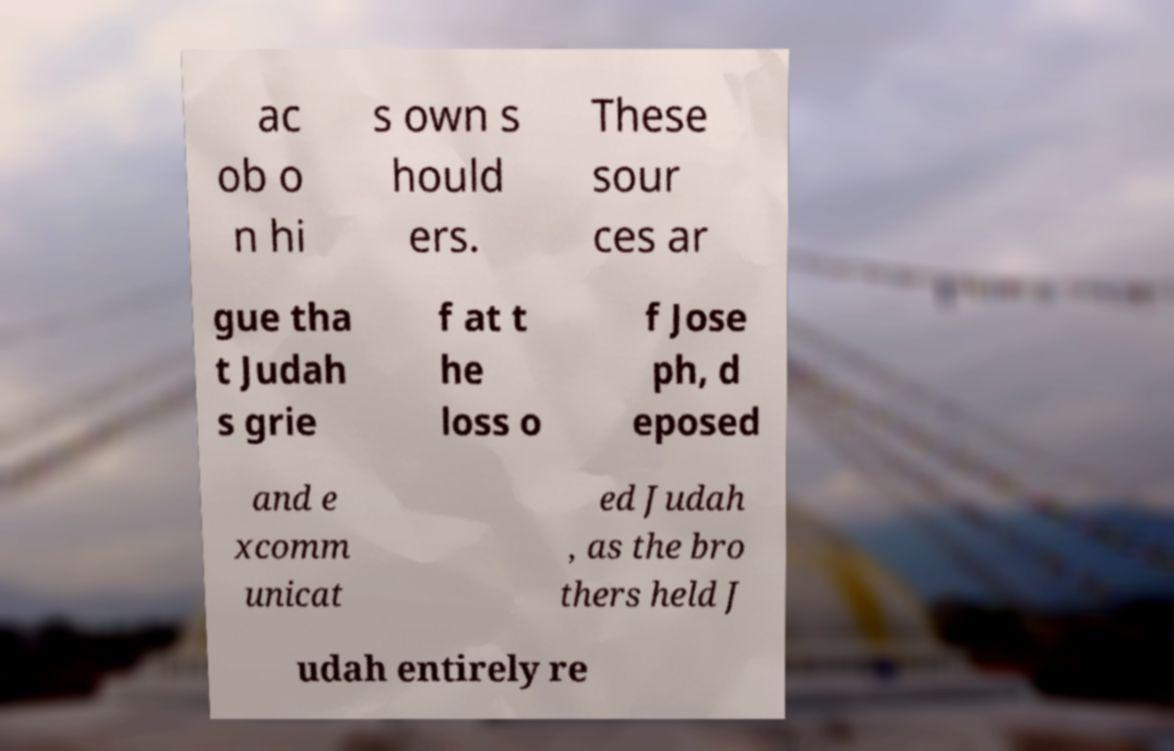Could you extract and type out the text from this image? ac ob o n hi s own s hould ers. These sour ces ar gue tha t Judah s grie f at t he loss o f Jose ph, d eposed and e xcomm unicat ed Judah , as the bro thers held J udah entirely re 